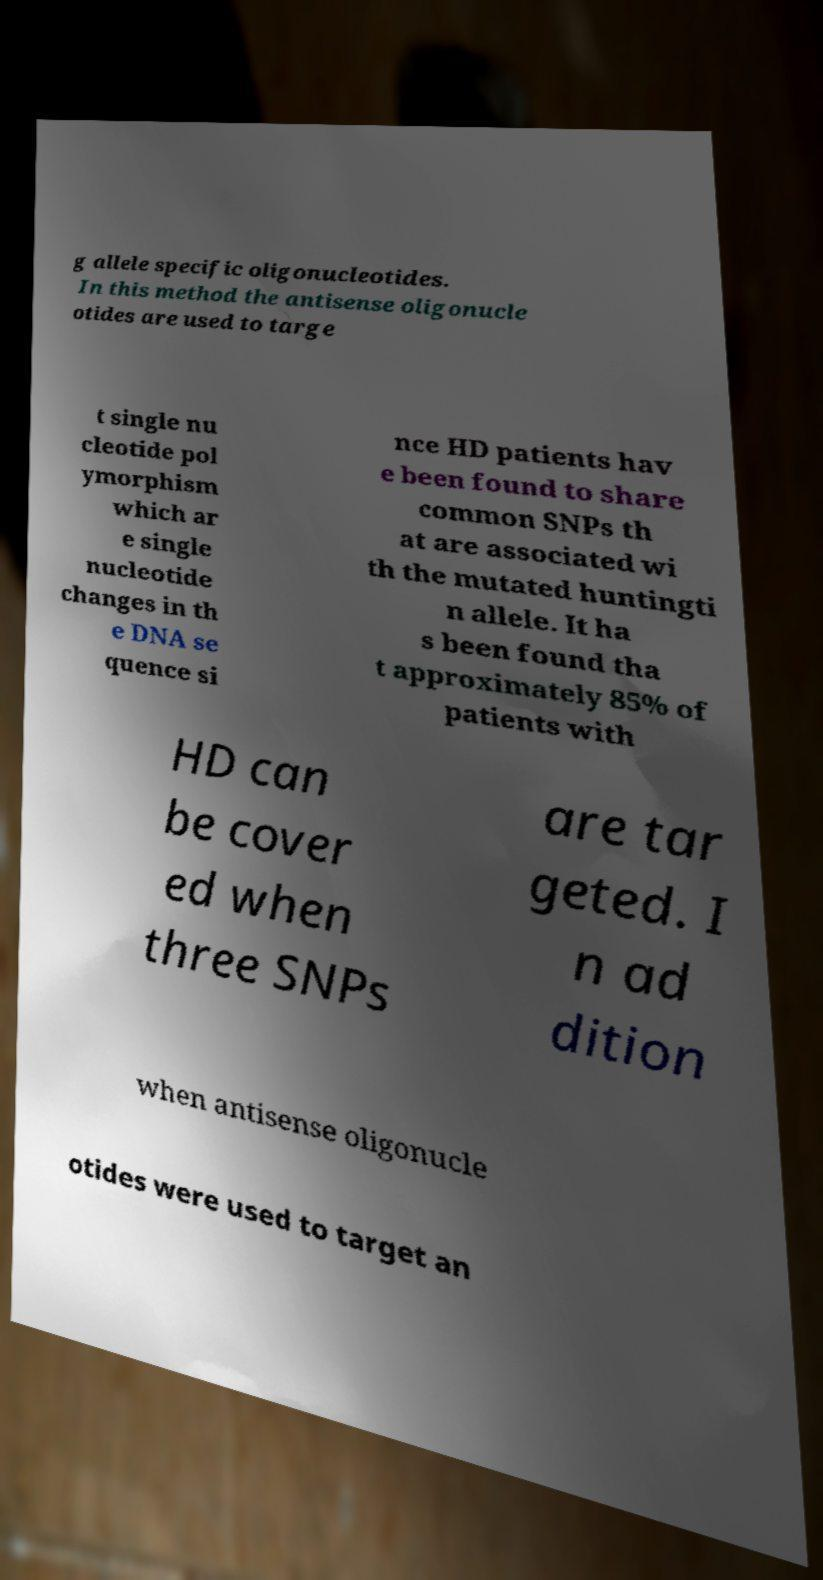Can you accurately transcribe the text from the provided image for me? g allele specific oligonucleotides. In this method the antisense oligonucle otides are used to targe t single nu cleotide pol ymorphism which ar e single nucleotide changes in th e DNA se quence si nce HD patients hav e been found to share common SNPs th at are associated wi th the mutated huntingti n allele. It ha s been found tha t approximately 85% of patients with HD can be cover ed when three SNPs are tar geted. I n ad dition when antisense oligonucle otides were used to target an 